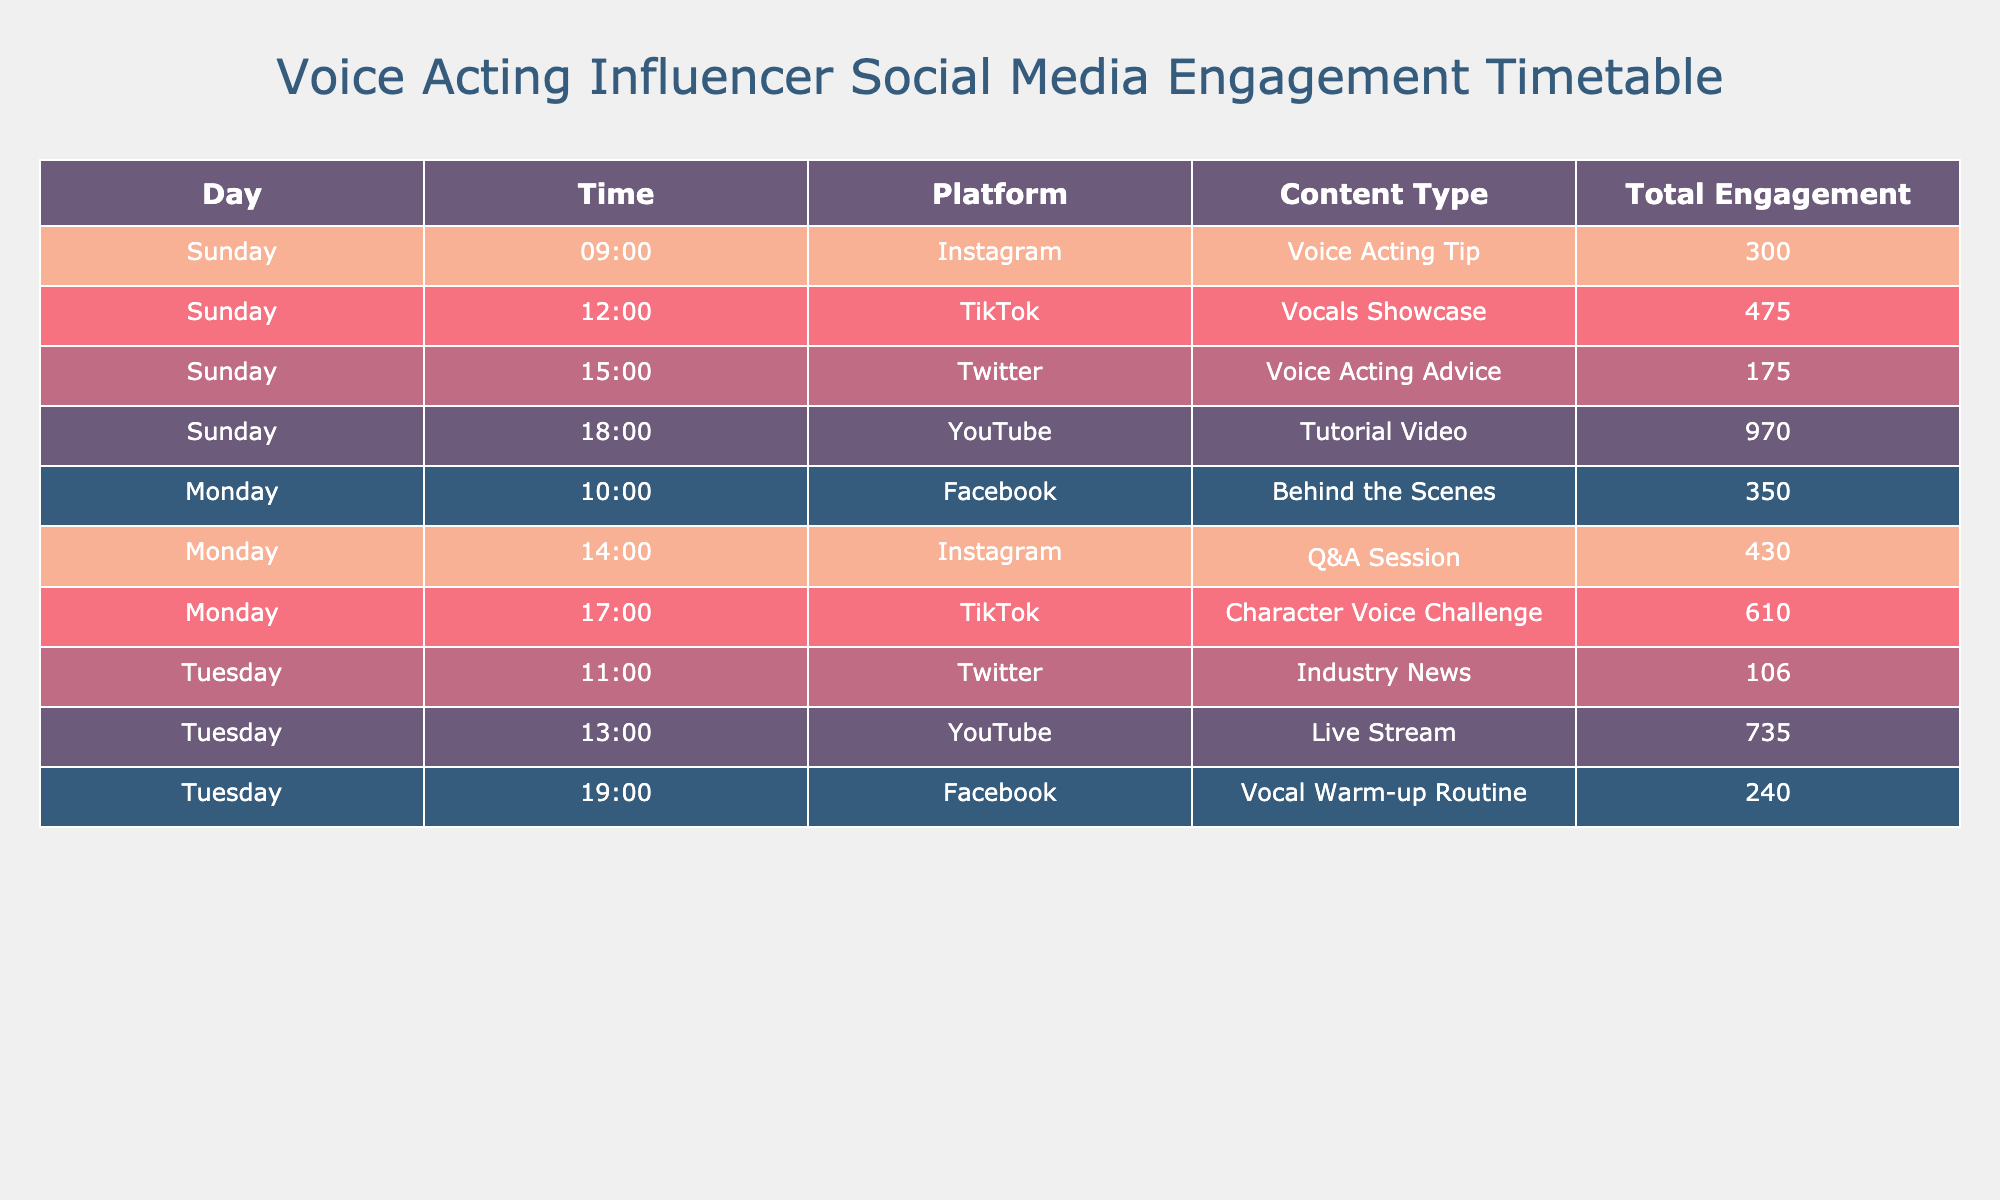What was the total engagement for the YouTube tutorial video on October 1st? The total engagement for the YouTube tutorial video on October 1st is found in the row corresponding to that date and platform. The table shows 970 total engagements for this entry.
Answer: 970 Which platform had the highest total engagement on October 2nd? To determine the platform with the highest total engagement on October 2nd, we examine the total engagement values for each entry dated October 2nd: Facebook has 350, Instagram has 430, and TikTok has 610. TikTok has the highest engagement of the three.
Answer: TikTok What is the average total engagement for all posts made on October 3rd? For October 3rd, the total engagements are: 106 (Twitter) + 735 (YouTube) + 240 (Facebook) = 1,081. There are 3 posts, so the average is 1,081 divided by 3, which equals approximately 360.33.
Answer: Approximately 360.33 Did the Instagram Q&A session have more likes than the TikTok Character Voice Challenge on October 2nd? The Instagram Q&A session received 350 likes, while the TikTok Character Voice Challenge received 500 likes on the same day. Since 500 is greater than 350, the statement is false.
Answer: No Which content type had the least total engagement across all platforms and dates? By reviewing the total engagement of each entry, we find Twitter's Industry News with a total engagement of 106 has the least engagement compared to the others listed in the table.
Answer: Voice Acting Advice If we consider the total engagements for Instagram on October 1st and October 2nd, what is their combined engagement? The total engagement for Instagram on October 1st is 300 (Voice Acting Tip) and on October 2nd is 430 (Q&A Session). Adding these gives 300 + 430 = 730 total engagements.
Answer: 730 Which content type received the least engagement on October 1st, and what was that engagement level? On October 1st, we review the engagements: Voice Acting Tip (300), Vocals Showcase (475), Voice Acting Advice (175), and Tutorial Video (970). The Voice Acting Advice received 175, making it the least.
Answer: Voice Acting Advice, 175 Was there any content type that received more than 800 total engagements? Checking all total engagement values from the table reveals that only the YouTube Tutorial Video on October 1st received engagements higher than 800, with a total of 970. Therefore, the answer is yes.
Answer: Yes 